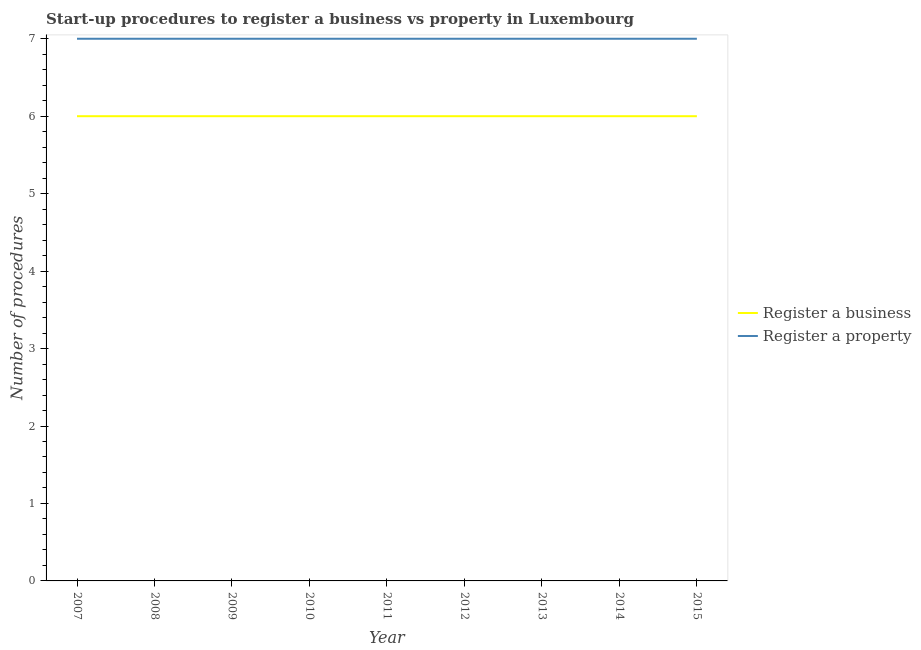How many different coloured lines are there?
Give a very brief answer. 2. Does the line corresponding to number of procedures to register a business intersect with the line corresponding to number of procedures to register a property?
Ensure brevity in your answer.  No. Is the number of lines equal to the number of legend labels?
Offer a terse response. Yes. What is the number of procedures to register a property in 2014?
Make the answer very short. 7. Across all years, what is the maximum number of procedures to register a property?
Offer a very short reply. 7. What is the total number of procedures to register a property in the graph?
Your answer should be very brief. 63. What is the difference between the number of procedures to register a business in 2010 and that in 2012?
Your answer should be compact. 0. What is the difference between the number of procedures to register a property in 2011 and the number of procedures to register a business in 2012?
Offer a very short reply. 1. What is the average number of procedures to register a business per year?
Offer a terse response. 6. In the year 2007, what is the difference between the number of procedures to register a business and number of procedures to register a property?
Your answer should be very brief. -1. Is the number of procedures to register a property in 2008 less than that in 2013?
Your answer should be compact. No. Is the difference between the number of procedures to register a business in 2011 and 2015 greater than the difference between the number of procedures to register a property in 2011 and 2015?
Provide a succinct answer. No. What is the difference between the highest and the second highest number of procedures to register a business?
Provide a short and direct response. 0. What is the difference between the highest and the lowest number of procedures to register a business?
Ensure brevity in your answer.  0. Is the sum of the number of procedures to register a property in 2007 and 2012 greater than the maximum number of procedures to register a business across all years?
Offer a very short reply. Yes. How many lines are there?
Make the answer very short. 2. Are the values on the major ticks of Y-axis written in scientific E-notation?
Your answer should be compact. No. Where does the legend appear in the graph?
Provide a succinct answer. Center right. How many legend labels are there?
Offer a terse response. 2. What is the title of the graph?
Offer a very short reply. Start-up procedures to register a business vs property in Luxembourg. Does "Exports" appear as one of the legend labels in the graph?
Ensure brevity in your answer.  No. What is the label or title of the Y-axis?
Your response must be concise. Number of procedures. What is the Number of procedures of Register a property in 2007?
Your response must be concise. 7. What is the Number of procedures of Register a business in 2008?
Provide a short and direct response. 6. What is the Number of procedures of Register a property in 2010?
Provide a succinct answer. 7. What is the Number of procedures of Register a property in 2011?
Make the answer very short. 7. What is the Number of procedures of Register a property in 2014?
Provide a succinct answer. 7. What is the Number of procedures in Register a business in 2015?
Offer a very short reply. 6. What is the Number of procedures in Register a property in 2015?
Keep it short and to the point. 7. Across all years, what is the maximum Number of procedures in Register a business?
Offer a terse response. 6. Across all years, what is the maximum Number of procedures of Register a property?
Give a very brief answer. 7. What is the total Number of procedures in Register a property in the graph?
Offer a very short reply. 63. What is the difference between the Number of procedures of Register a business in 2007 and that in 2008?
Ensure brevity in your answer.  0. What is the difference between the Number of procedures in Register a property in 2007 and that in 2009?
Your response must be concise. 0. What is the difference between the Number of procedures of Register a business in 2007 and that in 2010?
Offer a terse response. 0. What is the difference between the Number of procedures in Register a property in 2007 and that in 2012?
Offer a very short reply. 0. What is the difference between the Number of procedures in Register a business in 2007 and that in 2013?
Offer a very short reply. 0. What is the difference between the Number of procedures in Register a business in 2007 and that in 2014?
Your answer should be compact. 0. What is the difference between the Number of procedures of Register a property in 2007 and that in 2014?
Offer a terse response. 0. What is the difference between the Number of procedures of Register a business in 2007 and that in 2015?
Ensure brevity in your answer.  0. What is the difference between the Number of procedures in Register a property in 2007 and that in 2015?
Keep it short and to the point. 0. What is the difference between the Number of procedures of Register a business in 2008 and that in 2009?
Offer a terse response. 0. What is the difference between the Number of procedures in Register a business in 2008 and that in 2010?
Keep it short and to the point. 0. What is the difference between the Number of procedures in Register a property in 2008 and that in 2010?
Your answer should be very brief. 0. What is the difference between the Number of procedures in Register a business in 2008 and that in 2011?
Your answer should be compact. 0. What is the difference between the Number of procedures in Register a business in 2008 and that in 2013?
Keep it short and to the point. 0. What is the difference between the Number of procedures of Register a business in 2008 and that in 2015?
Give a very brief answer. 0. What is the difference between the Number of procedures of Register a property in 2008 and that in 2015?
Make the answer very short. 0. What is the difference between the Number of procedures of Register a property in 2009 and that in 2010?
Provide a short and direct response. 0. What is the difference between the Number of procedures in Register a property in 2009 and that in 2011?
Provide a succinct answer. 0. What is the difference between the Number of procedures in Register a business in 2009 and that in 2012?
Provide a succinct answer. 0. What is the difference between the Number of procedures in Register a property in 2009 and that in 2012?
Your response must be concise. 0. What is the difference between the Number of procedures of Register a business in 2009 and that in 2013?
Provide a short and direct response. 0. What is the difference between the Number of procedures of Register a property in 2009 and that in 2013?
Your answer should be compact. 0. What is the difference between the Number of procedures of Register a property in 2009 and that in 2014?
Offer a very short reply. 0. What is the difference between the Number of procedures in Register a business in 2009 and that in 2015?
Your answer should be very brief. 0. What is the difference between the Number of procedures of Register a business in 2010 and that in 2011?
Offer a terse response. 0. What is the difference between the Number of procedures in Register a business in 2010 and that in 2012?
Offer a very short reply. 0. What is the difference between the Number of procedures of Register a property in 2010 and that in 2012?
Offer a terse response. 0. What is the difference between the Number of procedures of Register a business in 2010 and that in 2015?
Your response must be concise. 0. What is the difference between the Number of procedures of Register a property in 2010 and that in 2015?
Keep it short and to the point. 0. What is the difference between the Number of procedures of Register a property in 2011 and that in 2012?
Offer a terse response. 0. What is the difference between the Number of procedures of Register a business in 2011 and that in 2014?
Give a very brief answer. 0. What is the difference between the Number of procedures of Register a property in 2011 and that in 2014?
Your answer should be very brief. 0. What is the difference between the Number of procedures of Register a business in 2011 and that in 2015?
Your response must be concise. 0. What is the difference between the Number of procedures of Register a property in 2011 and that in 2015?
Offer a terse response. 0. What is the difference between the Number of procedures in Register a business in 2012 and that in 2013?
Keep it short and to the point. 0. What is the difference between the Number of procedures of Register a business in 2012 and that in 2014?
Offer a terse response. 0. What is the difference between the Number of procedures of Register a property in 2012 and that in 2014?
Give a very brief answer. 0. What is the difference between the Number of procedures of Register a business in 2012 and that in 2015?
Your answer should be very brief. 0. What is the difference between the Number of procedures in Register a property in 2012 and that in 2015?
Provide a succinct answer. 0. What is the difference between the Number of procedures in Register a property in 2013 and that in 2015?
Your response must be concise. 0. What is the difference between the Number of procedures of Register a business in 2014 and that in 2015?
Your response must be concise. 0. What is the difference between the Number of procedures of Register a property in 2014 and that in 2015?
Your response must be concise. 0. What is the difference between the Number of procedures of Register a business in 2007 and the Number of procedures of Register a property in 2008?
Make the answer very short. -1. What is the difference between the Number of procedures of Register a business in 2007 and the Number of procedures of Register a property in 2010?
Ensure brevity in your answer.  -1. What is the difference between the Number of procedures of Register a business in 2007 and the Number of procedures of Register a property in 2013?
Provide a short and direct response. -1. What is the difference between the Number of procedures of Register a business in 2007 and the Number of procedures of Register a property in 2014?
Make the answer very short. -1. What is the difference between the Number of procedures of Register a business in 2007 and the Number of procedures of Register a property in 2015?
Provide a succinct answer. -1. What is the difference between the Number of procedures of Register a business in 2008 and the Number of procedures of Register a property in 2009?
Provide a succinct answer. -1. What is the difference between the Number of procedures of Register a business in 2008 and the Number of procedures of Register a property in 2011?
Ensure brevity in your answer.  -1. What is the difference between the Number of procedures of Register a business in 2008 and the Number of procedures of Register a property in 2012?
Provide a succinct answer. -1. What is the difference between the Number of procedures in Register a business in 2008 and the Number of procedures in Register a property in 2013?
Your answer should be very brief. -1. What is the difference between the Number of procedures of Register a business in 2008 and the Number of procedures of Register a property in 2014?
Offer a terse response. -1. What is the difference between the Number of procedures in Register a business in 2009 and the Number of procedures in Register a property in 2010?
Provide a short and direct response. -1. What is the difference between the Number of procedures in Register a business in 2009 and the Number of procedures in Register a property in 2012?
Your response must be concise. -1. What is the difference between the Number of procedures in Register a business in 2009 and the Number of procedures in Register a property in 2013?
Provide a short and direct response. -1. What is the difference between the Number of procedures of Register a business in 2010 and the Number of procedures of Register a property in 2011?
Give a very brief answer. -1. What is the difference between the Number of procedures in Register a business in 2010 and the Number of procedures in Register a property in 2012?
Make the answer very short. -1. What is the difference between the Number of procedures in Register a business in 2010 and the Number of procedures in Register a property in 2013?
Keep it short and to the point. -1. What is the difference between the Number of procedures of Register a business in 2010 and the Number of procedures of Register a property in 2015?
Your response must be concise. -1. What is the difference between the Number of procedures in Register a business in 2011 and the Number of procedures in Register a property in 2015?
Keep it short and to the point. -1. What is the difference between the Number of procedures in Register a business in 2012 and the Number of procedures in Register a property in 2013?
Provide a short and direct response. -1. What is the difference between the Number of procedures in Register a business in 2012 and the Number of procedures in Register a property in 2015?
Offer a very short reply. -1. What is the difference between the Number of procedures in Register a business in 2013 and the Number of procedures in Register a property in 2014?
Keep it short and to the point. -1. What is the difference between the Number of procedures of Register a business in 2013 and the Number of procedures of Register a property in 2015?
Provide a succinct answer. -1. What is the difference between the Number of procedures of Register a business in 2014 and the Number of procedures of Register a property in 2015?
Make the answer very short. -1. In the year 2007, what is the difference between the Number of procedures in Register a business and Number of procedures in Register a property?
Offer a terse response. -1. In the year 2008, what is the difference between the Number of procedures of Register a business and Number of procedures of Register a property?
Your answer should be very brief. -1. In the year 2009, what is the difference between the Number of procedures in Register a business and Number of procedures in Register a property?
Ensure brevity in your answer.  -1. In the year 2010, what is the difference between the Number of procedures of Register a business and Number of procedures of Register a property?
Ensure brevity in your answer.  -1. In the year 2013, what is the difference between the Number of procedures in Register a business and Number of procedures in Register a property?
Make the answer very short. -1. In the year 2014, what is the difference between the Number of procedures in Register a business and Number of procedures in Register a property?
Offer a very short reply. -1. In the year 2015, what is the difference between the Number of procedures of Register a business and Number of procedures of Register a property?
Make the answer very short. -1. What is the ratio of the Number of procedures in Register a property in 2007 to that in 2008?
Provide a succinct answer. 1. What is the ratio of the Number of procedures in Register a property in 2007 to that in 2009?
Offer a very short reply. 1. What is the ratio of the Number of procedures in Register a business in 2007 to that in 2010?
Make the answer very short. 1. What is the ratio of the Number of procedures of Register a property in 2007 to that in 2010?
Offer a very short reply. 1. What is the ratio of the Number of procedures of Register a business in 2007 to that in 2011?
Provide a short and direct response. 1. What is the ratio of the Number of procedures in Register a property in 2007 to that in 2011?
Your response must be concise. 1. What is the ratio of the Number of procedures in Register a business in 2007 to that in 2012?
Your answer should be compact. 1. What is the ratio of the Number of procedures of Register a property in 2007 to that in 2012?
Your answer should be very brief. 1. What is the ratio of the Number of procedures in Register a business in 2007 to that in 2013?
Your answer should be compact. 1. What is the ratio of the Number of procedures of Register a business in 2007 to that in 2015?
Offer a terse response. 1. What is the ratio of the Number of procedures in Register a business in 2008 to that in 2010?
Your answer should be compact. 1. What is the ratio of the Number of procedures in Register a business in 2008 to that in 2011?
Your answer should be compact. 1. What is the ratio of the Number of procedures in Register a property in 2008 to that in 2011?
Offer a terse response. 1. What is the ratio of the Number of procedures in Register a business in 2008 to that in 2012?
Make the answer very short. 1. What is the ratio of the Number of procedures in Register a property in 2008 to that in 2013?
Give a very brief answer. 1. What is the ratio of the Number of procedures in Register a business in 2008 to that in 2014?
Provide a short and direct response. 1. What is the ratio of the Number of procedures in Register a business in 2008 to that in 2015?
Provide a succinct answer. 1. What is the ratio of the Number of procedures of Register a property in 2008 to that in 2015?
Keep it short and to the point. 1. What is the ratio of the Number of procedures of Register a property in 2009 to that in 2010?
Make the answer very short. 1. What is the ratio of the Number of procedures of Register a business in 2009 to that in 2014?
Ensure brevity in your answer.  1. What is the ratio of the Number of procedures in Register a business in 2009 to that in 2015?
Your answer should be compact. 1. What is the ratio of the Number of procedures of Register a business in 2010 to that in 2011?
Ensure brevity in your answer.  1. What is the ratio of the Number of procedures in Register a property in 2010 to that in 2011?
Your response must be concise. 1. What is the ratio of the Number of procedures in Register a property in 2010 to that in 2014?
Your response must be concise. 1. What is the ratio of the Number of procedures of Register a business in 2010 to that in 2015?
Your answer should be very brief. 1. What is the ratio of the Number of procedures of Register a property in 2010 to that in 2015?
Your answer should be very brief. 1. What is the ratio of the Number of procedures of Register a business in 2011 to that in 2012?
Your answer should be very brief. 1. What is the ratio of the Number of procedures in Register a property in 2011 to that in 2013?
Keep it short and to the point. 1. What is the ratio of the Number of procedures in Register a property in 2011 to that in 2015?
Ensure brevity in your answer.  1. What is the ratio of the Number of procedures in Register a business in 2012 to that in 2014?
Give a very brief answer. 1. What is the ratio of the Number of procedures of Register a property in 2012 to that in 2015?
Ensure brevity in your answer.  1. What is the ratio of the Number of procedures of Register a business in 2013 to that in 2014?
Offer a terse response. 1. What is the ratio of the Number of procedures of Register a property in 2013 to that in 2014?
Offer a very short reply. 1. What is the ratio of the Number of procedures in Register a property in 2014 to that in 2015?
Offer a terse response. 1. What is the difference between the highest and the lowest Number of procedures of Register a property?
Offer a terse response. 0. 